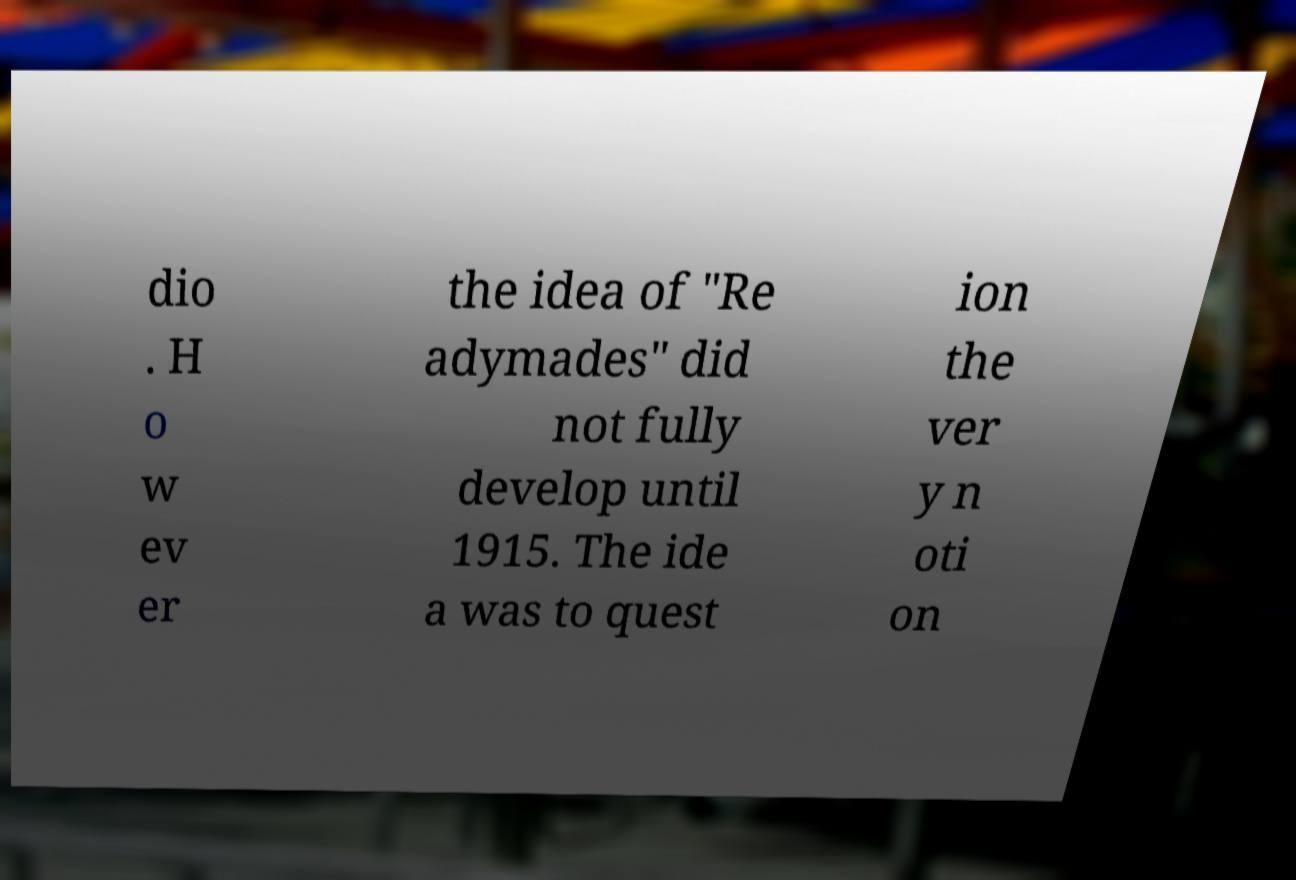Can you accurately transcribe the text from the provided image for me? dio . H o w ev er the idea of "Re adymades" did not fully develop until 1915. The ide a was to quest ion the ver y n oti on 